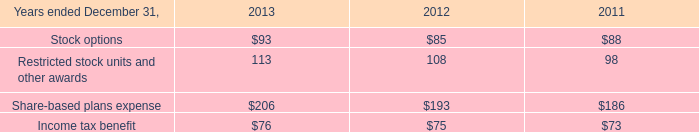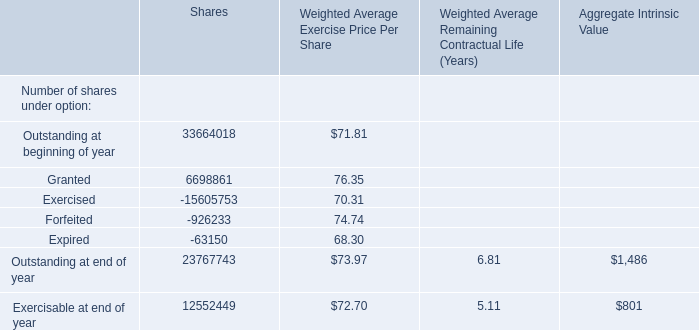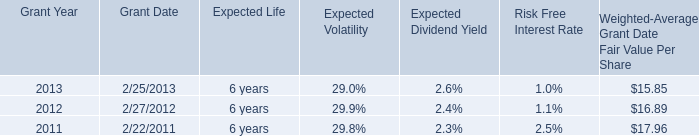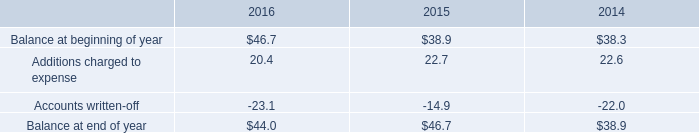what was the percentage change in the allowance for doubtful accounts in 2016 
Computations: ((44.0 - 46.7) / 46.7)
Answer: -0.05782. 